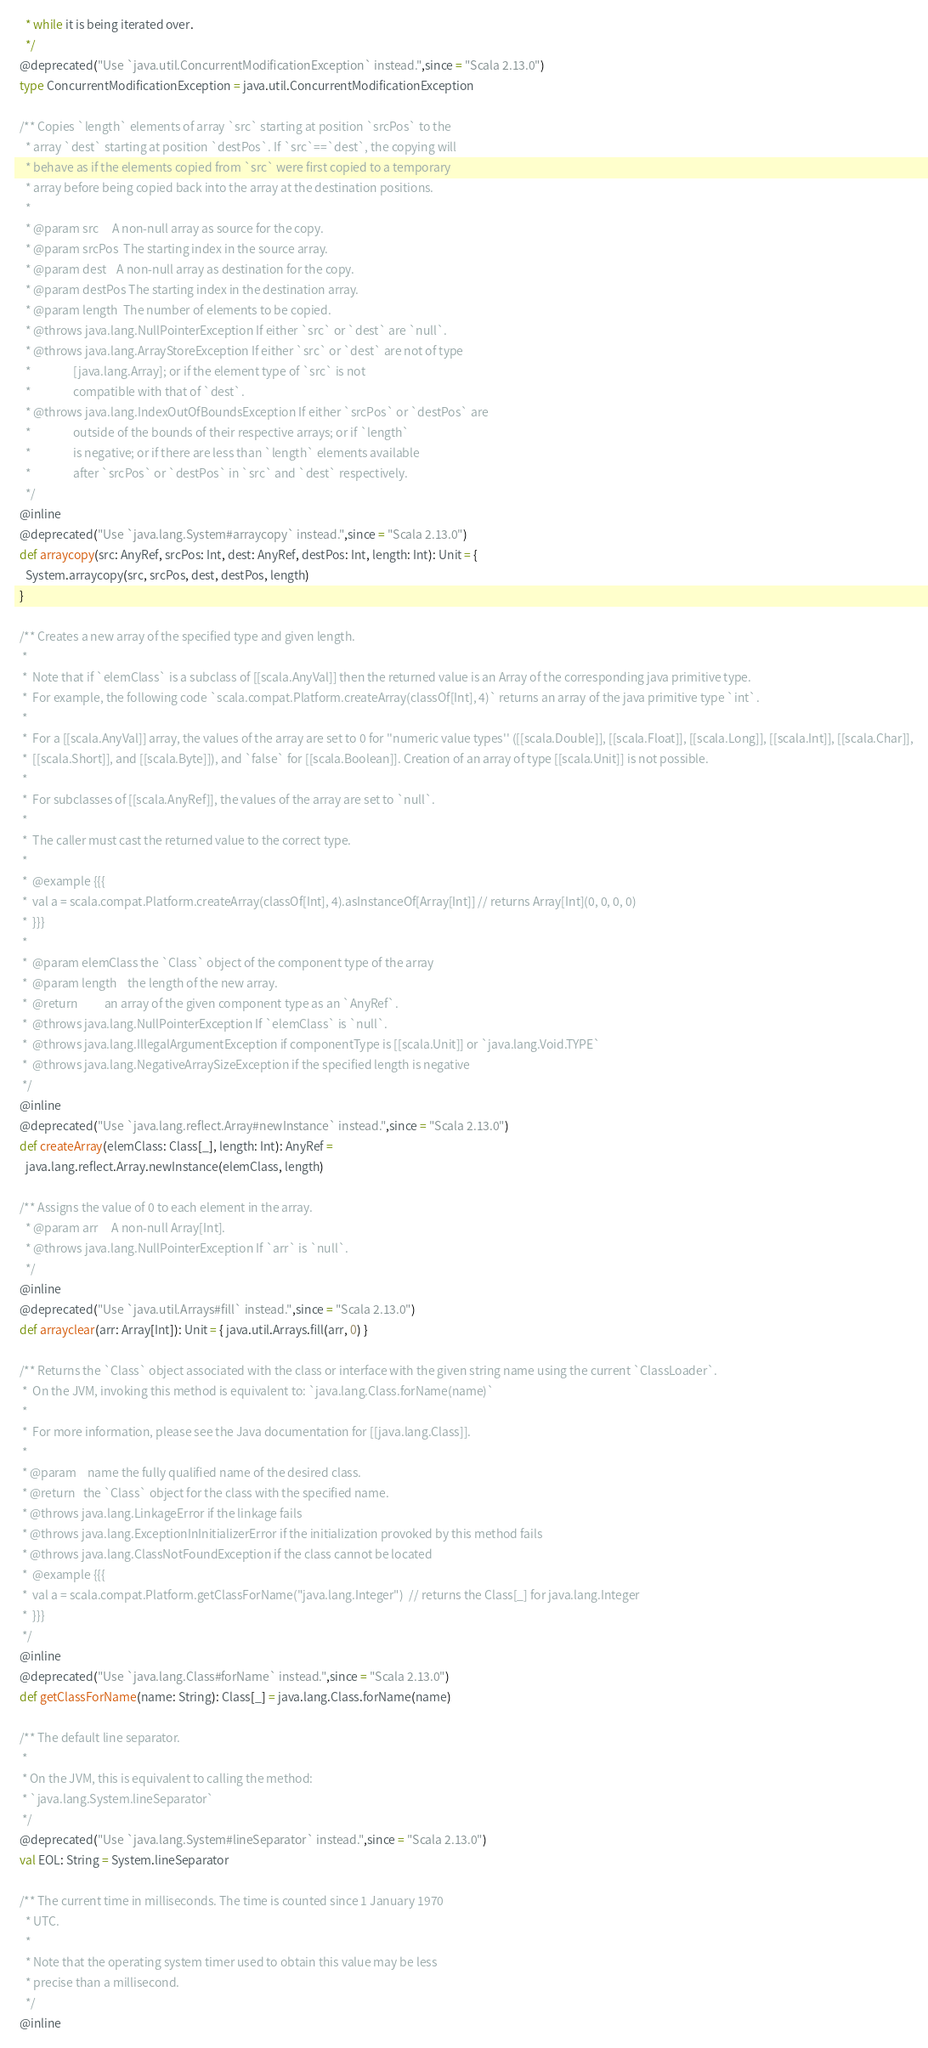Convert code to text. <code><loc_0><loc_0><loc_500><loc_500><_Scala_>    * while it is being iterated over.
    */
  @deprecated("Use `java.util.ConcurrentModificationException` instead.",since = "Scala 2.13.0")
  type ConcurrentModificationException = java.util.ConcurrentModificationException

  /** Copies `length` elements of array `src` starting at position `srcPos` to the
    * array `dest` starting at position `destPos`. If `src`==`dest`, the copying will
    * behave as if the elements copied from `src` were first copied to a temporary
    * array before being copied back into the array at the destination positions.
    *
    * @param src     A non-null array as source for the copy.
    * @param srcPos  The starting index in the source array.
    * @param dest    A non-null array as destination for the copy.
    * @param destPos The starting index in the destination array.
    * @param length  The number of elements to be copied.
    * @throws java.lang.NullPointerException If either `src` or `dest` are `null`.
    * @throws java.lang.ArrayStoreException If either `src` or `dest` are not of type
    *                [java.lang.Array]; or if the element type of `src` is not
    *                compatible with that of `dest`.
    * @throws java.lang.IndexOutOfBoundsException If either `srcPos` or `destPos` are
    *                outside of the bounds of their respective arrays; or if `length`
    *                is negative; or if there are less than `length` elements available
    *                after `srcPos` or `destPos` in `src` and `dest` respectively.
    */
  @inline
  @deprecated("Use `java.lang.System#arraycopy` instead.",since = "Scala 2.13.0")
  def arraycopy(src: AnyRef, srcPos: Int, dest: AnyRef, destPos: Int, length: Int): Unit = {
    System.arraycopy(src, srcPos, dest, destPos, length)
  }

  /** Creates a new array of the specified type and given length.
   *
   *  Note that if `elemClass` is a subclass of [[scala.AnyVal]] then the returned value is an Array of the corresponding java primitive type.
   *  For example, the following code `scala.compat.Platform.createArray(classOf[Int], 4)` returns an array of the java primitive type `int`.
   *
   *  For a [[scala.AnyVal]] array, the values of the array are set to 0 for ''numeric value types'' ([[scala.Double]], [[scala.Float]], [[scala.Long]], [[scala.Int]], [[scala.Char]],
   *  [[scala.Short]], and [[scala.Byte]]), and `false` for [[scala.Boolean]]. Creation of an array of type [[scala.Unit]] is not possible.
   *
   *  For subclasses of [[scala.AnyRef]], the values of the array are set to `null`.
   *
   *  The caller must cast the returned value to the correct type.
   *
   *  @example {{{
   *  val a = scala.compat.Platform.createArray(classOf[Int], 4).asInstanceOf[Array[Int]] // returns Array[Int](0, 0, 0, 0)
   *  }}}
   *
   *  @param elemClass the `Class` object of the component type of the array
   *  @param length    the length of the new array.
   *  @return          an array of the given component type as an `AnyRef`.
   *  @throws java.lang.NullPointerException If `elemClass` is `null`.
   *  @throws java.lang.IllegalArgumentException if componentType is [[scala.Unit]] or `java.lang.Void.TYPE`
   *  @throws java.lang.NegativeArraySizeException if the specified length is negative
   */
  @inline
  @deprecated("Use `java.lang.reflect.Array#newInstance` instead.",since = "Scala 2.13.0")
  def createArray(elemClass: Class[_], length: Int): AnyRef =
    java.lang.reflect.Array.newInstance(elemClass, length)

  /** Assigns the value of 0 to each element in the array.
    * @param arr     A non-null Array[Int].
    * @throws java.lang.NullPointerException If `arr` is `null`.
    */
  @inline
  @deprecated("Use `java.util.Arrays#fill` instead.",since = "Scala 2.13.0")
  def arrayclear(arr: Array[Int]): Unit = { java.util.Arrays.fill(arr, 0) }

  /** Returns the `Class` object associated with the class or interface with the given string name using the current `ClassLoader`.
   *  On the JVM, invoking this method is equivalent to: `java.lang.Class.forName(name)`
   *
   *  For more information, please see the Java documentation for [[java.lang.Class]].
   *
   * @param    name the fully qualified name of the desired class.
   * @return   the `Class` object for the class with the specified name.
   * @throws java.lang.LinkageError if the linkage fails
   * @throws java.lang.ExceptionInInitializerError if the initialization provoked by this method fails
   * @throws java.lang.ClassNotFoundException if the class cannot be located
   *  @example {{{
   *  val a = scala.compat.Platform.getClassForName("java.lang.Integer")  // returns the Class[_] for java.lang.Integer
   *  }}}
   */
  @inline
  @deprecated("Use `java.lang.Class#forName` instead.",since = "Scala 2.13.0")
  def getClassForName(name: String): Class[_] = java.lang.Class.forName(name)

  /** The default line separator.
   *
   * On the JVM, this is equivalent to calling the method:
   * `java.lang.System.lineSeparator`
   */
  @deprecated("Use `java.lang.System#lineSeparator` instead.",since = "Scala 2.13.0")
  val EOL: String = System.lineSeparator

  /** The current time in milliseconds. The time is counted since 1 January 1970
    * UTC.
    *
    * Note that the operating system timer used to obtain this value may be less
    * precise than a millisecond.
    */
  @inline</code> 